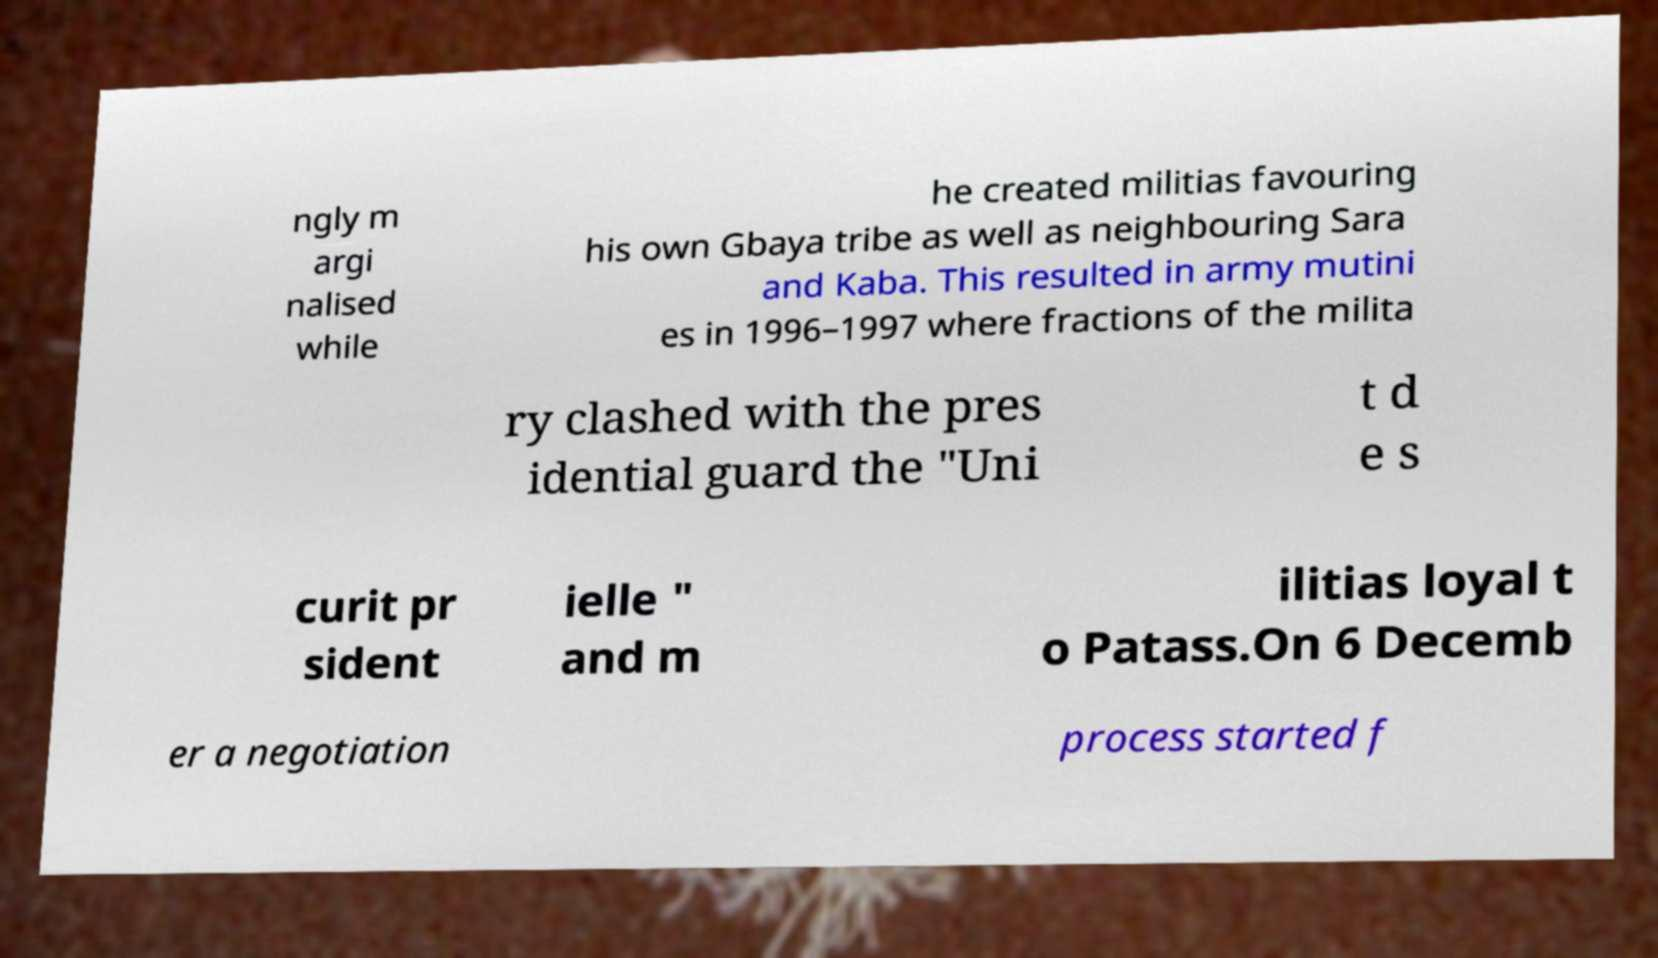What messages or text are displayed in this image? I need them in a readable, typed format. ngly m argi nalised while he created militias favouring his own Gbaya tribe as well as neighbouring Sara and Kaba. This resulted in army mutini es in 1996–1997 where fractions of the milita ry clashed with the pres idential guard the "Uni t d e s curit pr sident ielle " and m ilitias loyal t o Patass.On 6 Decemb er a negotiation process started f 